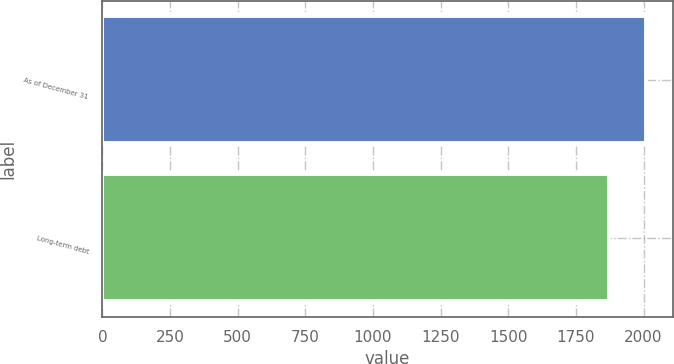<chart> <loc_0><loc_0><loc_500><loc_500><bar_chart><fcel>As of December 31<fcel>Long-term debt<nl><fcel>2008<fcel>1872<nl></chart> 